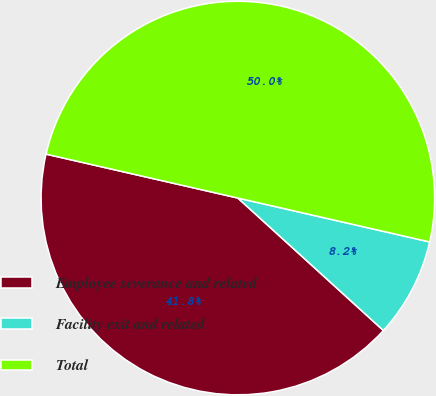Convert chart. <chart><loc_0><loc_0><loc_500><loc_500><pie_chart><fcel>Employee severance and related<fcel>Facility exit and related<fcel>Total<nl><fcel>41.83%<fcel>8.17%<fcel>50.0%<nl></chart> 